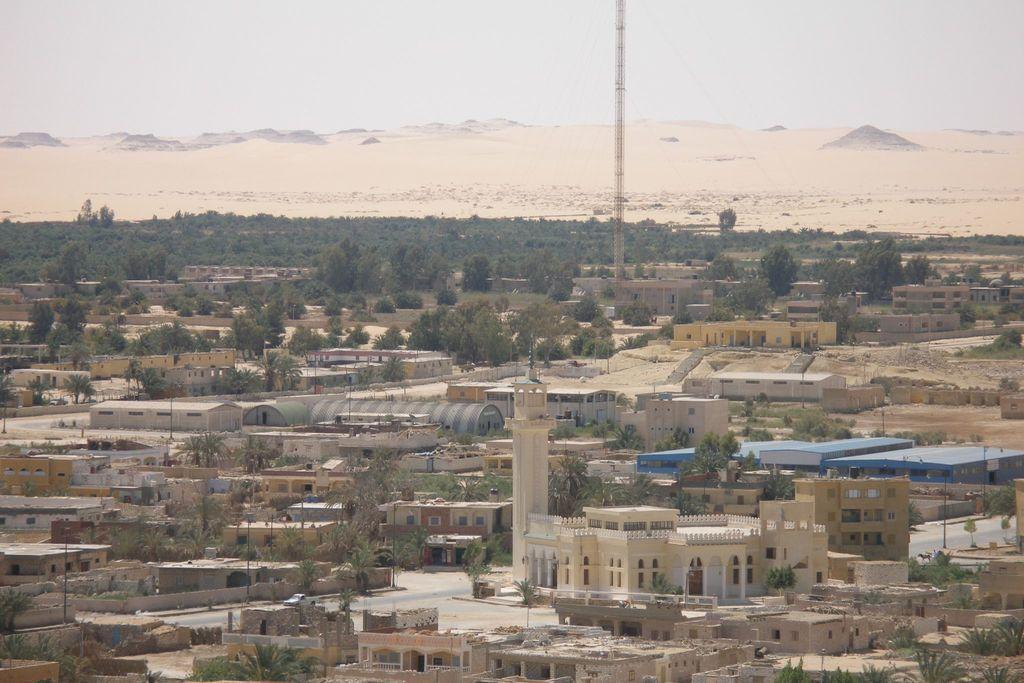How would you summarize this image in a sentence or two? In this image I can see few buildings, windows, trees, metal tower and the sky is in white color. 